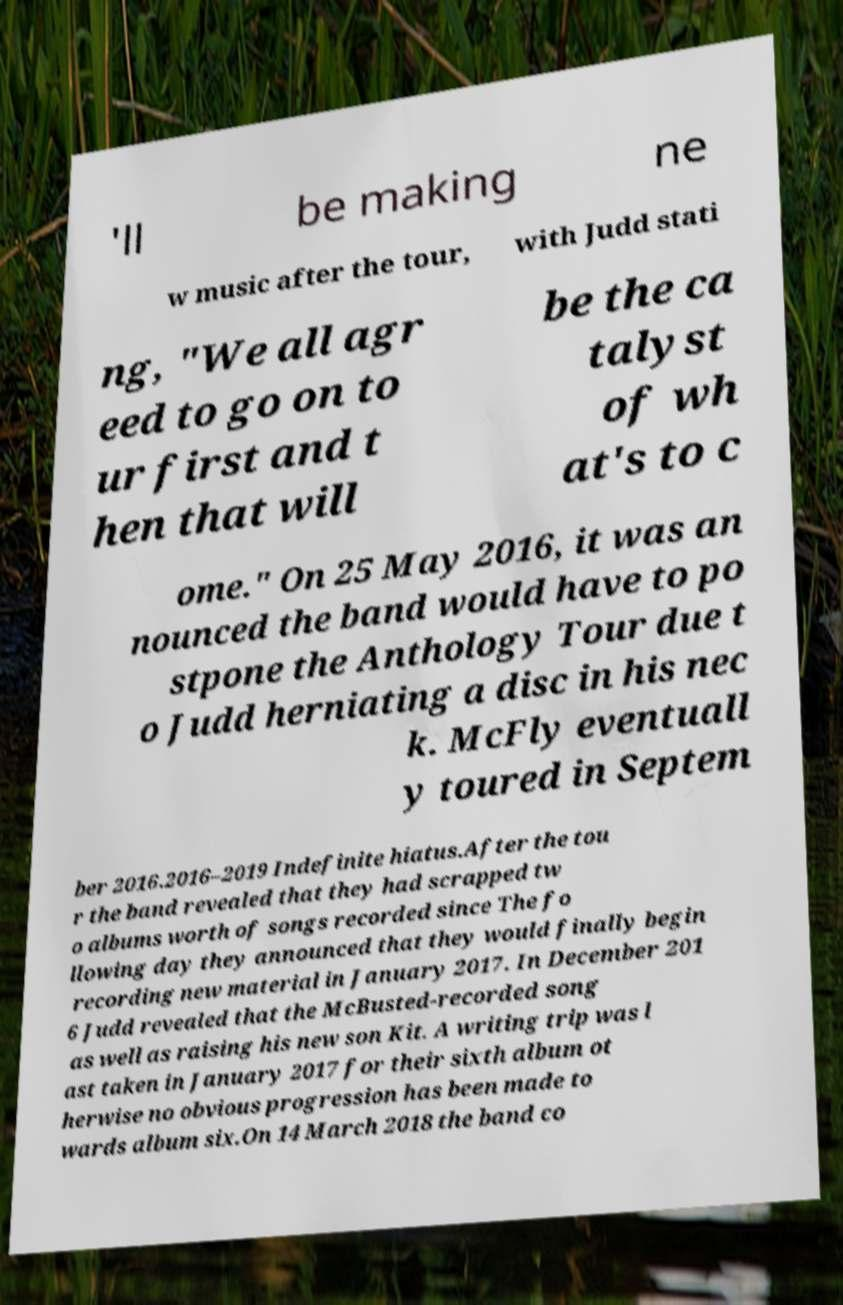For documentation purposes, I need the text within this image transcribed. Could you provide that? 'll be making ne w music after the tour, with Judd stati ng, "We all agr eed to go on to ur first and t hen that will be the ca talyst of wh at's to c ome." On 25 May 2016, it was an nounced the band would have to po stpone the Anthology Tour due t o Judd herniating a disc in his nec k. McFly eventuall y toured in Septem ber 2016.2016–2019 Indefinite hiatus.After the tou r the band revealed that they had scrapped tw o albums worth of songs recorded since The fo llowing day they announced that they would finally begin recording new material in January 2017. In December 201 6 Judd revealed that the McBusted-recorded song as well as raising his new son Kit. A writing trip was l ast taken in January 2017 for their sixth album ot herwise no obvious progression has been made to wards album six.On 14 March 2018 the band co 